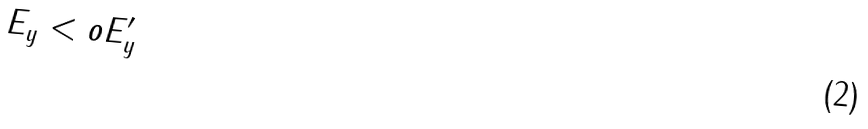Convert formula to latex. <formula><loc_0><loc_0><loc_500><loc_500>E _ { y } < o E ^ { \prime } _ { y }</formula> 